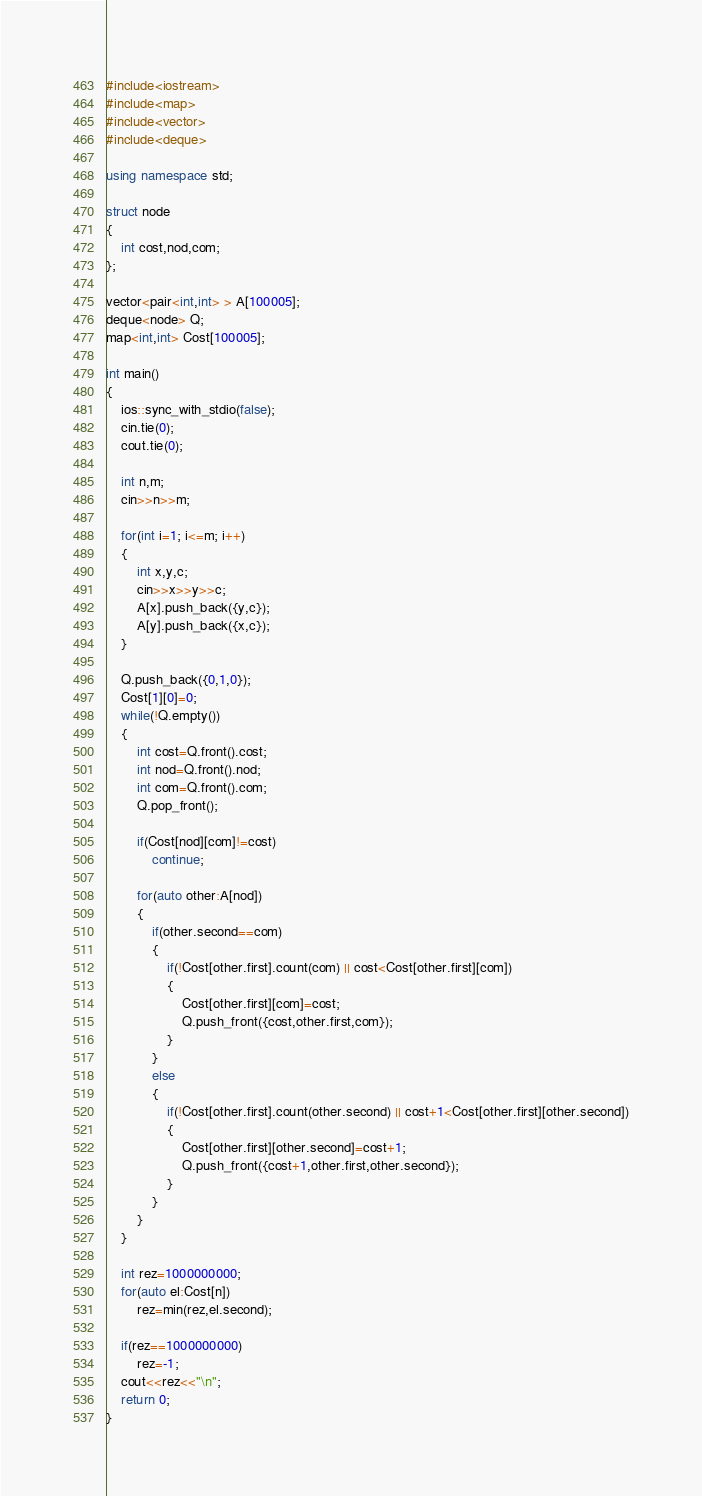<code> <loc_0><loc_0><loc_500><loc_500><_C++_>#include<iostream>
#include<map>
#include<vector>
#include<deque>

using namespace std;

struct node
{
    int cost,nod,com;
};

vector<pair<int,int> > A[100005];
deque<node> Q;
map<int,int> Cost[100005];

int main()
{
	ios::sync_with_stdio(false);
	cin.tie(0);
	cout.tie(0);

    int n,m;
    cin>>n>>m;

    for(int i=1; i<=m; i++)
    {
        int x,y,c;
        cin>>x>>y>>c;
        A[x].push_back({y,c});
        A[y].push_back({x,c});
    }

    Q.push_back({0,1,0});
    Cost[1][0]=0;
    while(!Q.empty())
    {
        int cost=Q.front().cost;
        int nod=Q.front().nod;
        int com=Q.front().com;
        Q.pop_front();

        if(Cost[nod][com]!=cost)
            continue;

        for(auto other:A[nod])
        {
            if(other.second==com)
            {
                if(!Cost[other.first].count(com) || cost<Cost[other.first][com])
                {
                    Cost[other.first][com]=cost;
                    Q.push_front({cost,other.first,com});
                }
            }
            else
            {
                if(!Cost[other.first].count(other.second) || cost+1<Cost[other.first][other.second])
                {
                    Cost[other.first][other.second]=cost+1;
                    Q.push_front({cost+1,other.first,other.second});
                }
            }
        }
    }

    int rez=1000000000;
    for(auto el:Cost[n])
        rez=min(rez,el.second);

    if(rez==1000000000)
        rez=-1;
    cout<<rez<<"\n";
    return 0;
}
</code> 